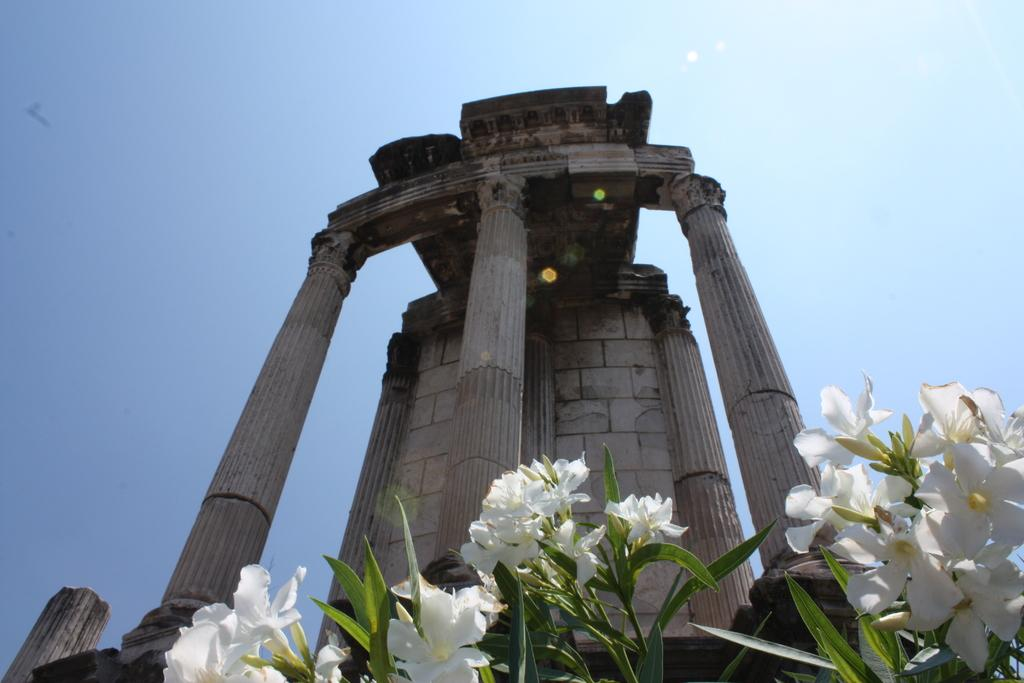What type of architecture is depicted in the image? The image features ancient architecture. Can you describe any specific features of the architecture? The architecture includes pillars. What type of plants can be seen in the image? There are plants with white flowers, buds, and leaves in the image. What is visible in the background of the image? The sky is visible in the image. Can you tell me how many baseballs are lying on the ground in the image? There are no baseballs present in the image; it features ancient architecture and plants. What type of comb is being used to style the plants in the image? There is no comb present in the image; the plants are naturally growing with white flowers, buds, and leaves. 